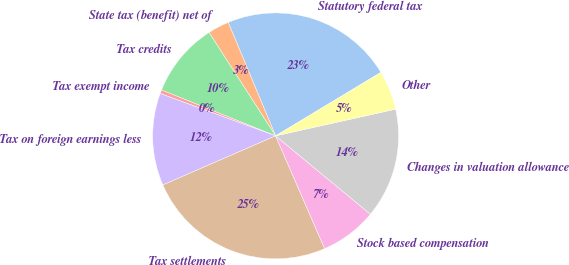Convert chart. <chart><loc_0><loc_0><loc_500><loc_500><pie_chart><fcel>Statutory federal tax<fcel>State tax (benefit) net of<fcel>Tax credits<fcel>Tax exempt income<fcel>Tax on foreign earnings less<fcel>Tax settlements<fcel>Stock based compensation<fcel>Changes in valuation allowance<fcel>Other<nl><fcel>22.66%<fcel>2.81%<fcel>9.81%<fcel>0.48%<fcel>12.14%<fcel>24.99%<fcel>7.48%<fcel>14.48%<fcel>5.15%<nl></chart> 